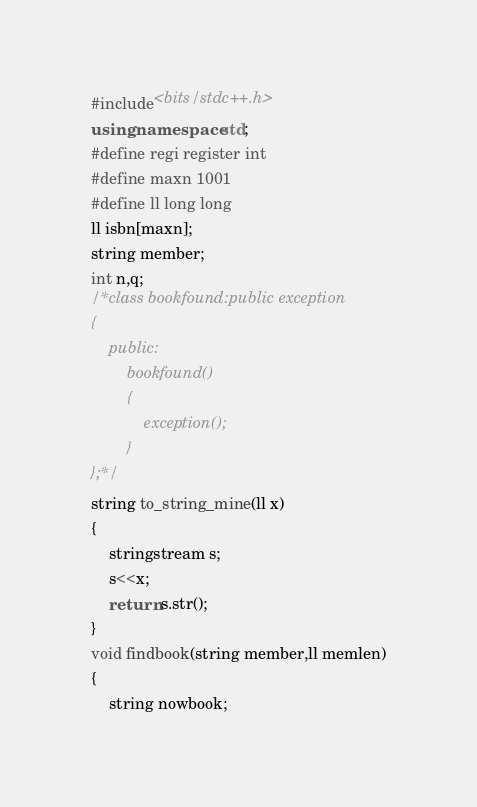<code> <loc_0><loc_0><loc_500><loc_500><_C++_>#include<bits/stdc++.h>
using namespace std;
#define regi register int
#define maxn 1001
#define ll long long
ll isbn[maxn];
string member;
int n,q;
/*class bookfound:public exception
{
    public:
        bookfound()
        {
            exception();
        }
};*/
string to_string_mine(ll x)
{
    stringstream s;
    s<<x;
    return s.str();
}
void findbook(string member,ll memlen)
{
    string nowbook;</code> 